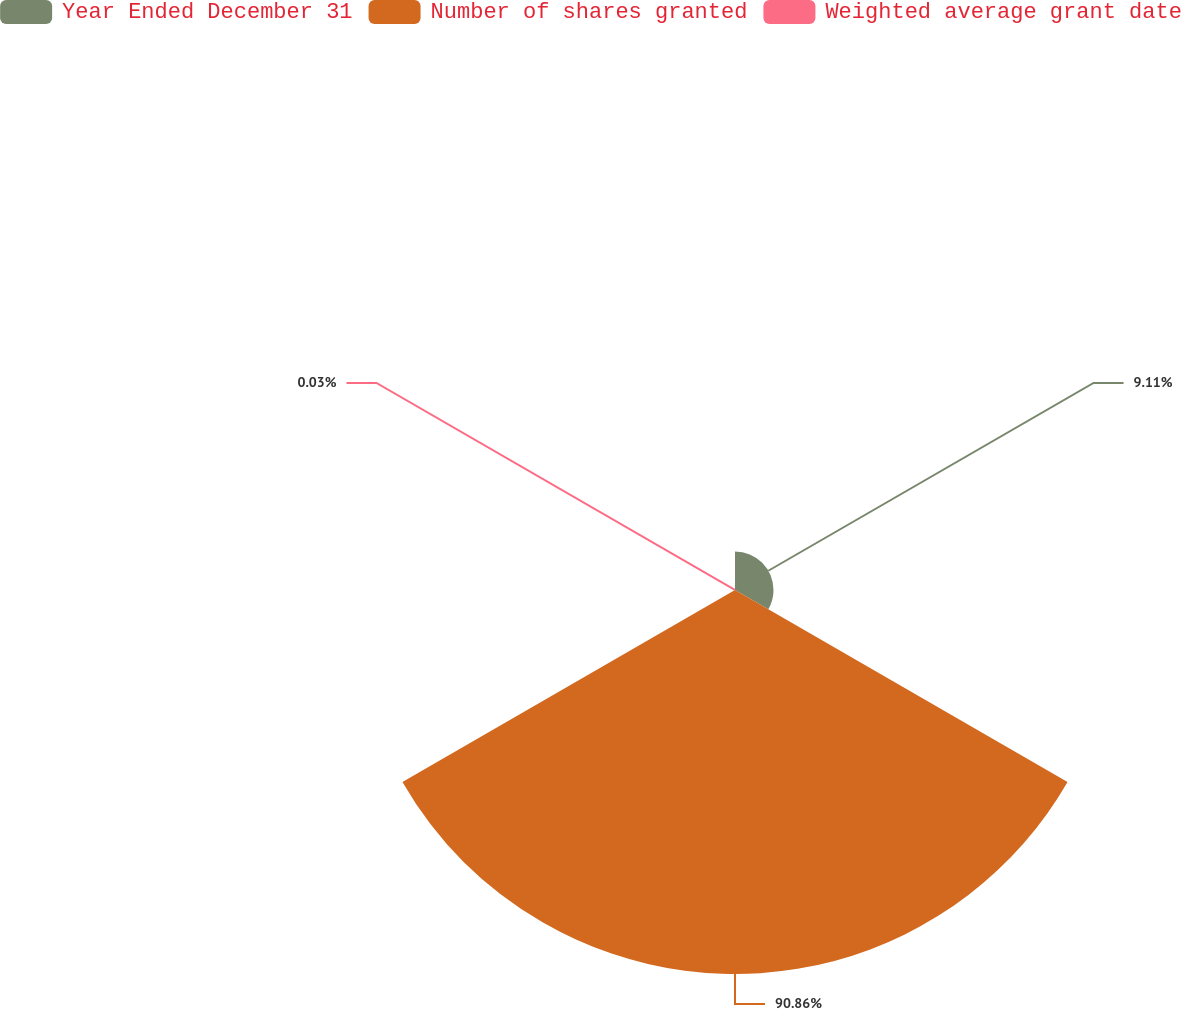Convert chart to OTSL. <chart><loc_0><loc_0><loc_500><loc_500><pie_chart><fcel>Year Ended December 31<fcel>Number of shares granted<fcel>Weighted average grant date<nl><fcel>9.11%<fcel>90.86%<fcel>0.03%<nl></chart> 